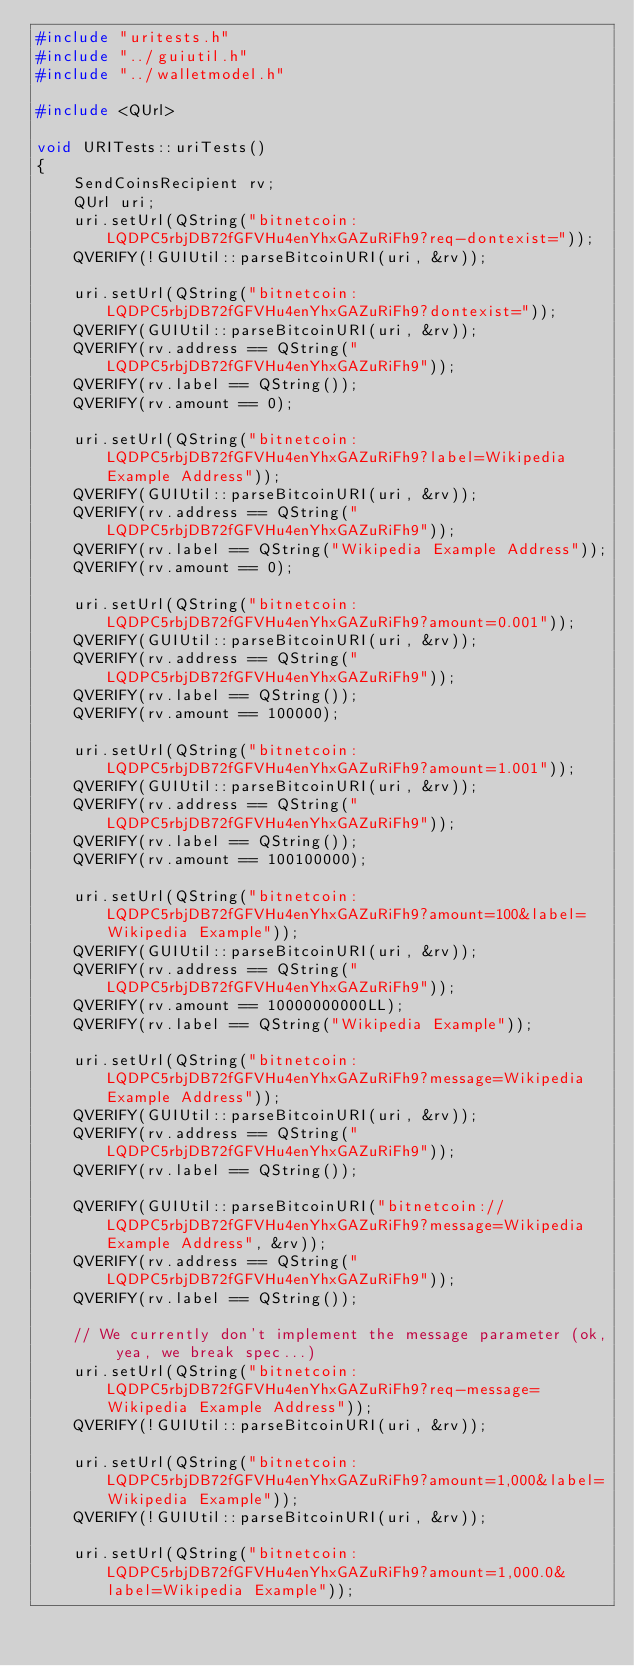<code> <loc_0><loc_0><loc_500><loc_500><_C++_>#include "uritests.h"
#include "../guiutil.h"
#include "../walletmodel.h"

#include <QUrl>

void URITests::uriTests()
{
    SendCoinsRecipient rv;
    QUrl uri;
    uri.setUrl(QString("bitnetcoin:LQDPC5rbjDB72fGFVHu4enYhxGAZuRiFh9?req-dontexist="));
    QVERIFY(!GUIUtil::parseBitcoinURI(uri, &rv));

    uri.setUrl(QString("bitnetcoin:LQDPC5rbjDB72fGFVHu4enYhxGAZuRiFh9?dontexist="));
    QVERIFY(GUIUtil::parseBitcoinURI(uri, &rv));
    QVERIFY(rv.address == QString("LQDPC5rbjDB72fGFVHu4enYhxGAZuRiFh9"));
    QVERIFY(rv.label == QString());
    QVERIFY(rv.amount == 0);

    uri.setUrl(QString("bitnetcoin:LQDPC5rbjDB72fGFVHu4enYhxGAZuRiFh9?label=Wikipedia Example Address"));
    QVERIFY(GUIUtil::parseBitcoinURI(uri, &rv));
    QVERIFY(rv.address == QString("LQDPC5rbjDB72fGFVHu4enYhxGAZuRiFh9"));
    QVERIFY(rv.label == QString("Wikipedia Example Address"));
    QVERIFY(rv.amount == 0);

    uri.setUrl(QString("bitnetcoin:LQDPC5rbjDB72fGFVHu4enYhxGAZuRiFh9?amount=0.001"));
    QVERIFY(GUIUtil::parseBitcoinURI(uri, &rv));
    QVERIFY(rv.address == QString("LQDPC5rbjDB72fGFVHu4enYhxGAZuRiFh9"));
    QVERIFY(rv.label == QString());
    QVERIFY(rv.amount == 100000);

    uri.setUrl(QString("bitnetcoin:LQDPC5rbjDB72fGFVHu4enYhxGAZuRiFh9?amount=1.001"));
    QVERIFY(GUIUtil::parseBitcoinURI(uri, &rv));
    QVERIFY(rv.address == QString("LQDPC5rbjDB72fGFVHu4enYhxGAZuRiFh9"));
    QVERIFY(rv.label == QString());
    QVERIFY(rv.amount == 100100000);

    uri.setUrl(QString("bitnetcoin:LQDPC5rbjDB72fGFVHu4enYhxGAZuRiFh9?amount=100&label=Wikipedia Example"));
    QVERIFY(GUIUtil::parseBitcoinURI(uri, &rv));
    QVERIFY(rv.address == QString("LQDPC5rbjDB72fGFVHu4enYhxGAZuRiFh9"));
    QVERIFY(rv.amount == 10000000000LL);
    QVERIFY(rv.label == QString("Wikipedia Example"));

    uri.setUrl(QString("bitnetcoin:LQDPC5rbjDB72fGFVHu4enYhxGAZuRiFh9?message=Wikipedia Example Address"));
    QVERIFY(GUIUtil::parseBitcoinURI(uri, &rv));
    QVERIFY(rv.address == QString("LQDPC5rbjDB72fGFVHu4enYhxGAZuRiFh9"));
    QVERIFY(rv.label == QString());

    QVERIFY(GUIUtil::parseBitcoinURI("bitnetcoin://LQDPC5rbjDB72fGFVHu4enYhxGAZuRiFh9?message=Wikipedia Example Address", &rv));
    QVERIFY(rv.address == QString("LQDPC5rbjDB72fGFVHu4enYhxGAZuRiFh9"));
    QVERIFY(rv.label == QString());

    // We currently don't implement the message parameter (ok, yea, we break spec...)
    uri.setUrl(QString("bitnetcoin:LQDPC5rbjDB72fGFVHu4enYhxGAZuRiFh9?req-message=Wikipedia Example Address"));
    QVERIFY(!GUIUtil::parseBitcoinURI(uri, &rv));

    uri.setUrl(QString("bitnetcoin:LQDPC5rbjDB72fGFVHu4enYhxGAZuRiFh9?amount=1,000&label=Wikipedia Example"));
    QVERIFY(!GUIUtil::parseBitcoinURI(uri, &rv));

    uri.setUrl(QString("bitnetcoin:LQDPC5rbjDB72fGFVHu4enYhxGAZuRiFh9?amount=1,000.0&label=Wikipedia Example"));</code> 